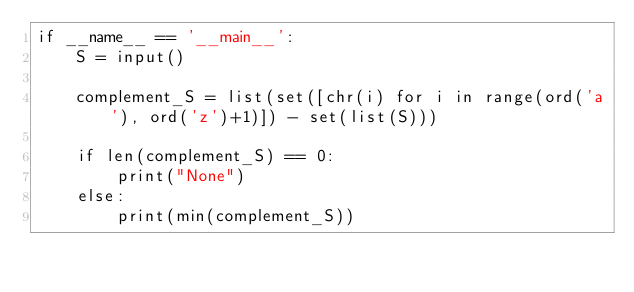<code> <loc_0><loc_0><loc_500><loc_500><_Python_>if __name__ == '__main__':
    S = input()

    complement_S = list(set([chr(i) for i in range(ord('a'), ord('z')+1)]) - set(list(S)))

    if len(complement_S) == 0:
        print("None")
    else:
        print(min(complement_S))</code> 